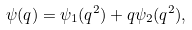Convert formula to latex. <formula><loc_0><loc_0><loc_500><loc_500>\psi ( q ) = \psi _ { 1 } ( q ^ { 2 } ) + q \psi _ { 2 } ( q ^ { 2 } ) ,</formula> 